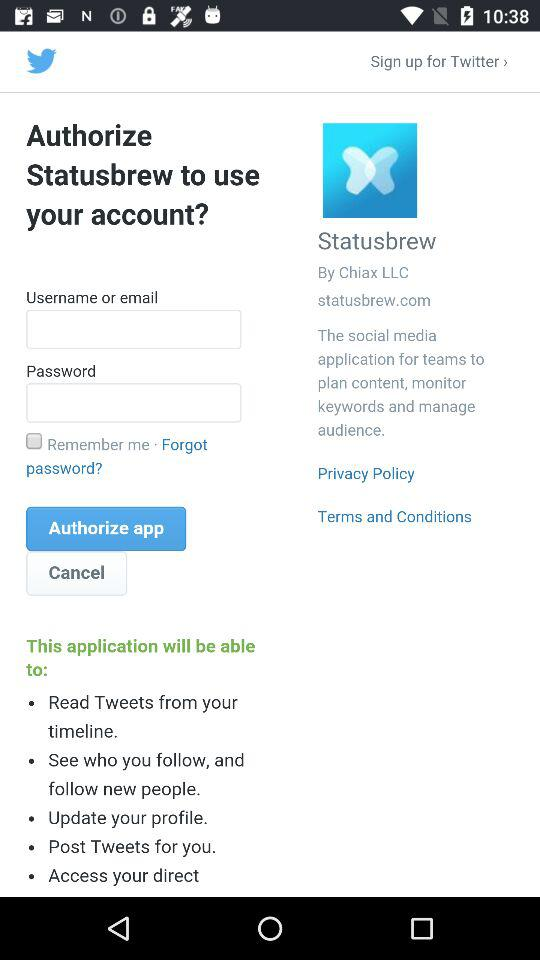What are some of the points mentioned about the application? Some of the points mentioned about the application are "Read Tweets from your timeline.", "See who you follow, and follow new people.", "Update your profile.", "Post Tweets for you." and "Access your direct". 